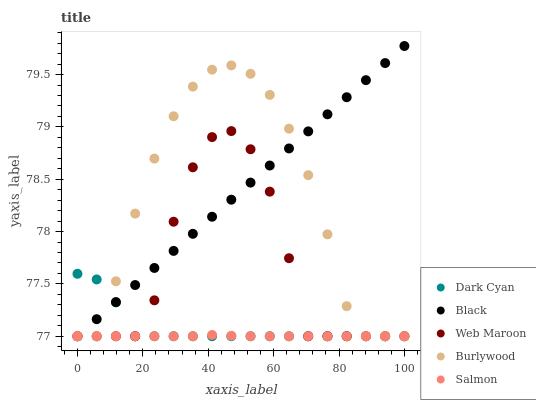Does Salmon have the minimum area under the curve?
Answer yes or no. Yes. Does Black have the maximum area under the curve?
Answer yes or no. Yes. Does Web Maroon have the minimum area under the curve?
Answer yes or no. No. Does Web Maroon have the maximum area under the curve?
Answer yes or no. No. Is Black the smoothest?
Answer yes or no. Yes. Is Web Maroon the roughest?
Answer yes or no. Yes. Is Web Maroon the smoothest?
Answer yes or no. No. Is Black the roughest?
Answer yes or no. No. Does Dark Cyan have the lowest value?
Answer yes or no. Yes. Does Black have the highest value?
Answer yes or no. Yes. Does Web Maroon have the highest value?
Answer yes or no. No. Does Burlywood intersect Salmon?
Answer yes or no. Yes. Is Burlywood less than Salmon?
Answer yes or no. No. Is Burlywood greater than Salmon?
Answer yes or no. No. 